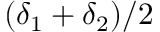<formula> <loc_0><loc_0><loc_500><loc_500>( \delta _ { 1 } + \delta _ { 2 } ) / 2</formula> 